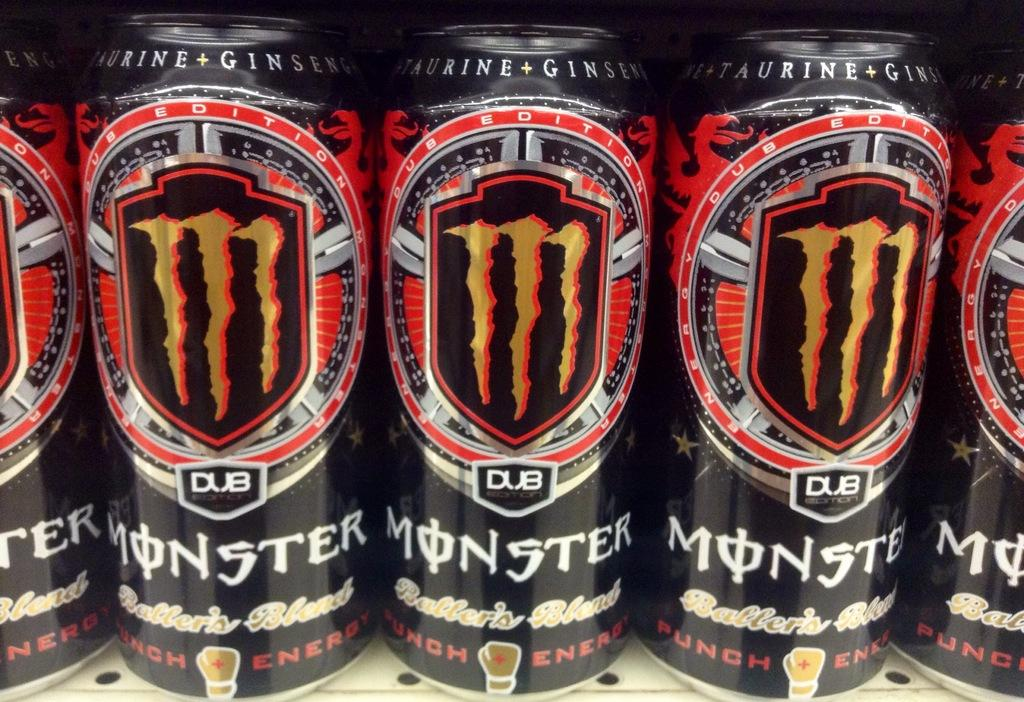<image>
Present a compact description of the photo's key features. Several cans of Monster energy drink on a shelf 